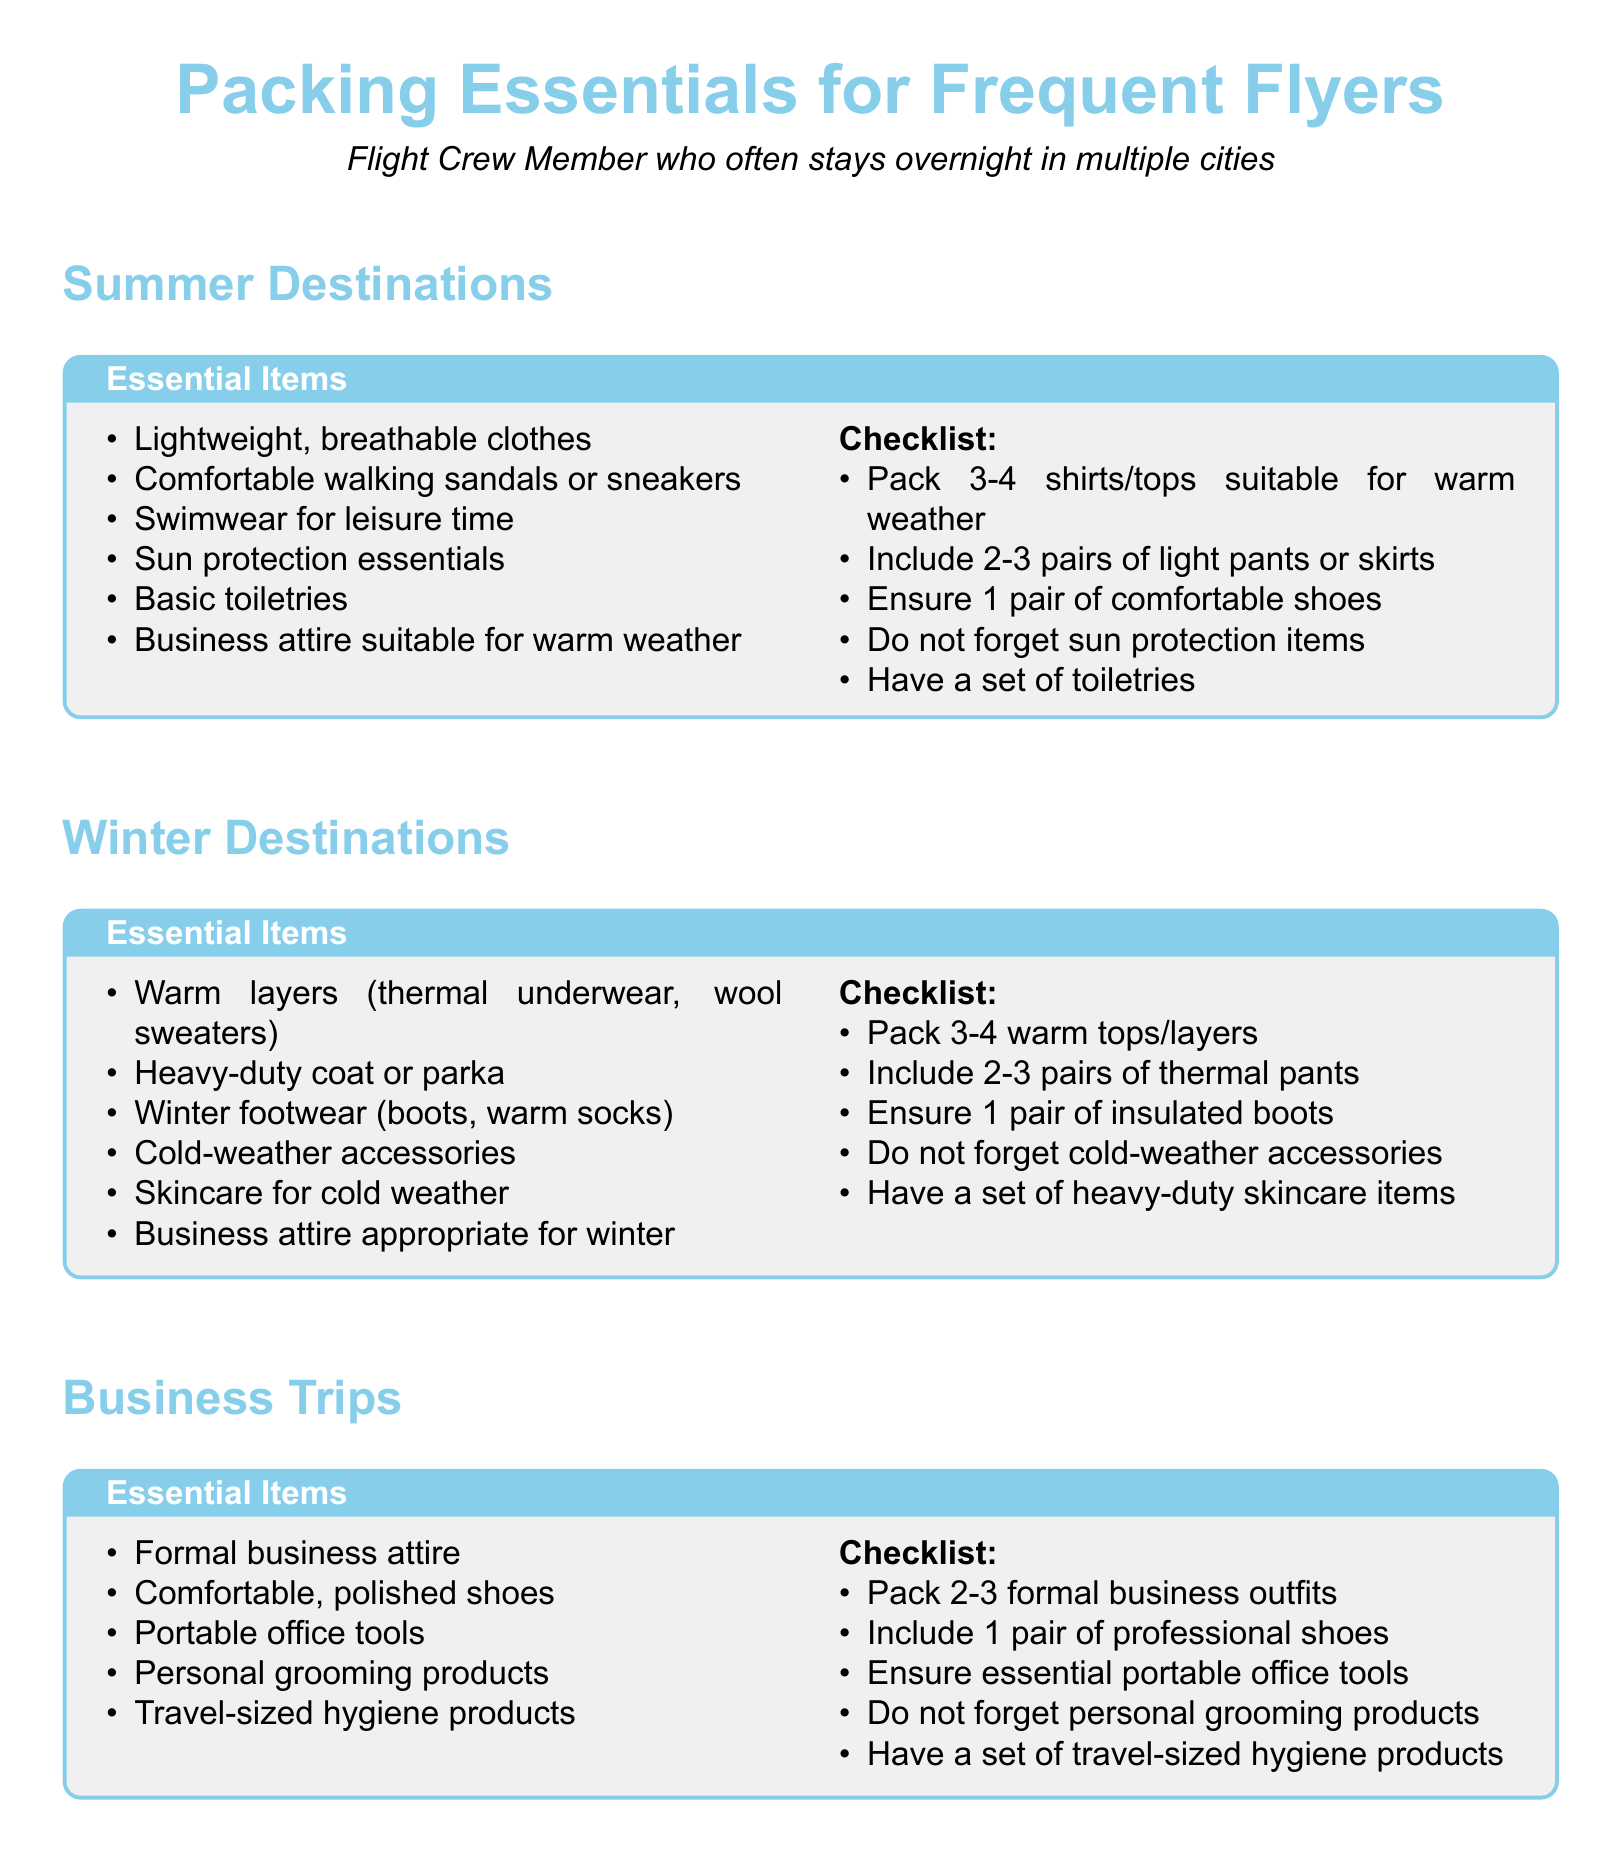What items are essential for summer destinations? The document lists lightweight clothes, comfortable sandals, swimwear, sun protection essentials, basic toiletries, and business attire for summer destinations.
Answer: Lightweight, breathable clothes How many warm tops should you pack for winter destinations? The checklist for winter destinations recommends packing 3-4 warm tops/layers.
Answer: 3-4 What type of shoes are recommended for business trips? The essential items for business trips suggest having comfortable, polished shoes.
Answer: Comfortable, polished shoes What is included in the checklist for leisurely stays? The checklist for leisurely stays includes packing 3-4 casual outfits, 1-2 pairs of comfortable footwear, entertainment devices, personal comfort items, and leisure-related accessories.
Answer: 3-4 casual outfits What is the recommended winter outerwear? The document states that a heavy-duty coat or parka is essential for winter destinations.
Answer: Heavy-duty coat or parka Which category includes portable office tools? The essential items for business trips mention portable office tools.
Answer: Business Trips What should you not forget when packing for summer? The checklist emphasizes not forgetting sun protection items for summer packing.
Answer: Sun protection items How many formal business outfits should you pack? The checklist for business trips recommends packing 2-3 formal business outfits.
Answer: 2-3 